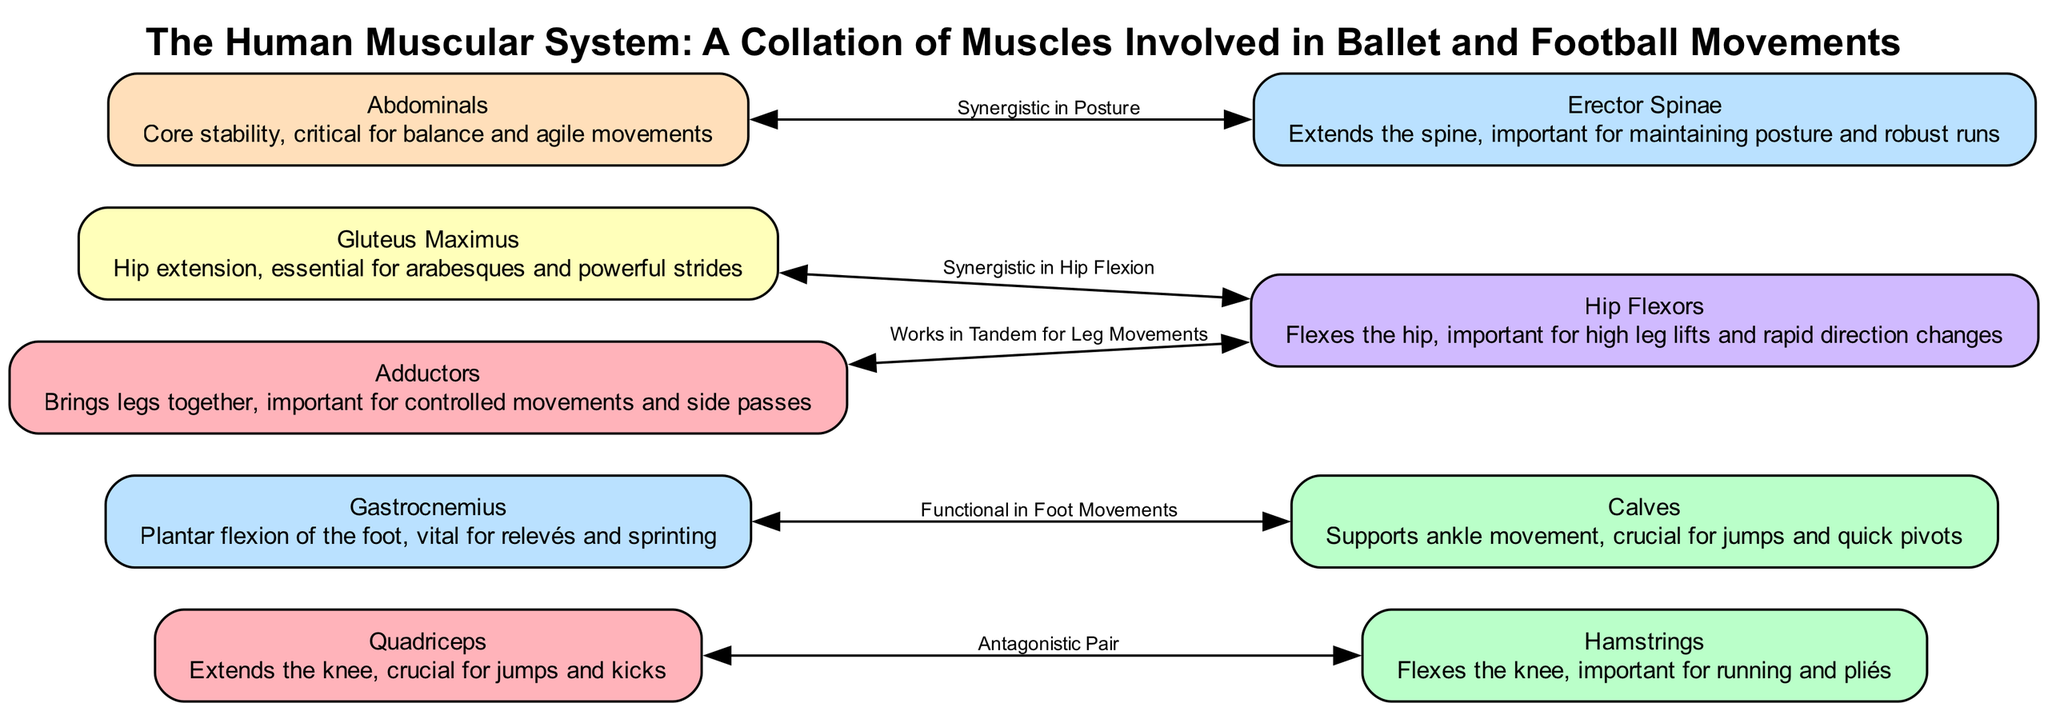What is the primary function of the Quadriceps? The Quadriceps is described in the diagram as extending the knee, which is crucial for jumps and kicks, indicating its primary role in those actions.
Answer: Extends the knee How many muscles are illustrated in the diagram? By counting the listed nodes in the diagram, there are a total of nine muscles involved in the system, as each node represents a distinct muscle group.
Answer: Nine Which two muscles are considered an antagonistic pair? The diagram specifies a relationship between the Quadriceps and the Hamstrings, indicating that they work against each other, identifying them as an antagonistic pair.
Answer: Quadriceps and Hamstrings What is the role of the Abdominals in ballet and football? The diagram highlights that the Abdominals provide core stability, which is critical for maintaining balance and facilitating agile movements in both disciplines.
Answer: Core stability Which muscles work together for hip flexion? The diagram establishes that the Gluteus Maximus and Hip Flexors work synergistically in hip flexion, signifying their cooperative function during this movement.
Answer: Gluteus Maximus and Hip Flexors How many synergistic relationships are depicted in the diagram? The diagram shows three specified synergistic relationships, connecting various muscles as they work together to support different functions.
Answer: Three What is the description of the Erector Spinae in the context of movement? The diagram outlines the Erector Spinae as extending the spine, which is important for maintaining posture and facilitating robust movements like running.
Answer: Extends the spine Which muscles are involved in foot movements? The diagram notes that the Gastrocnemius and Calves are functionally connected, supporting ankle movement, which is crucial for actions requiring foot mobility, such as jumping.
Answer: Gastrocnemius and Calves What relationship do Adductors and Hip Flexors have in leg movements? According to the diagram, the Adductors work in tandem with the Hip Flexors, meaning they collaboratively contribute to smooth and controlled leg movements during activities.
Answer: Works in tandem for leg movements 